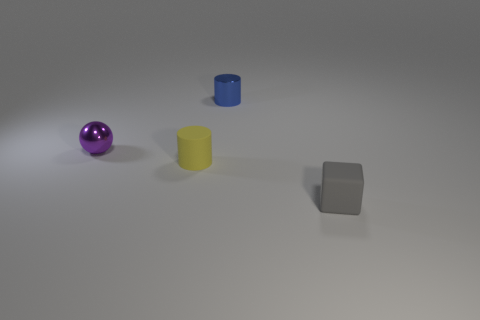The purple shiny thing is what shape? The purple shiny object in the image is a sphere, exhibiting a reflective surface that likely indicates it's made out of a smooth, polished material. 